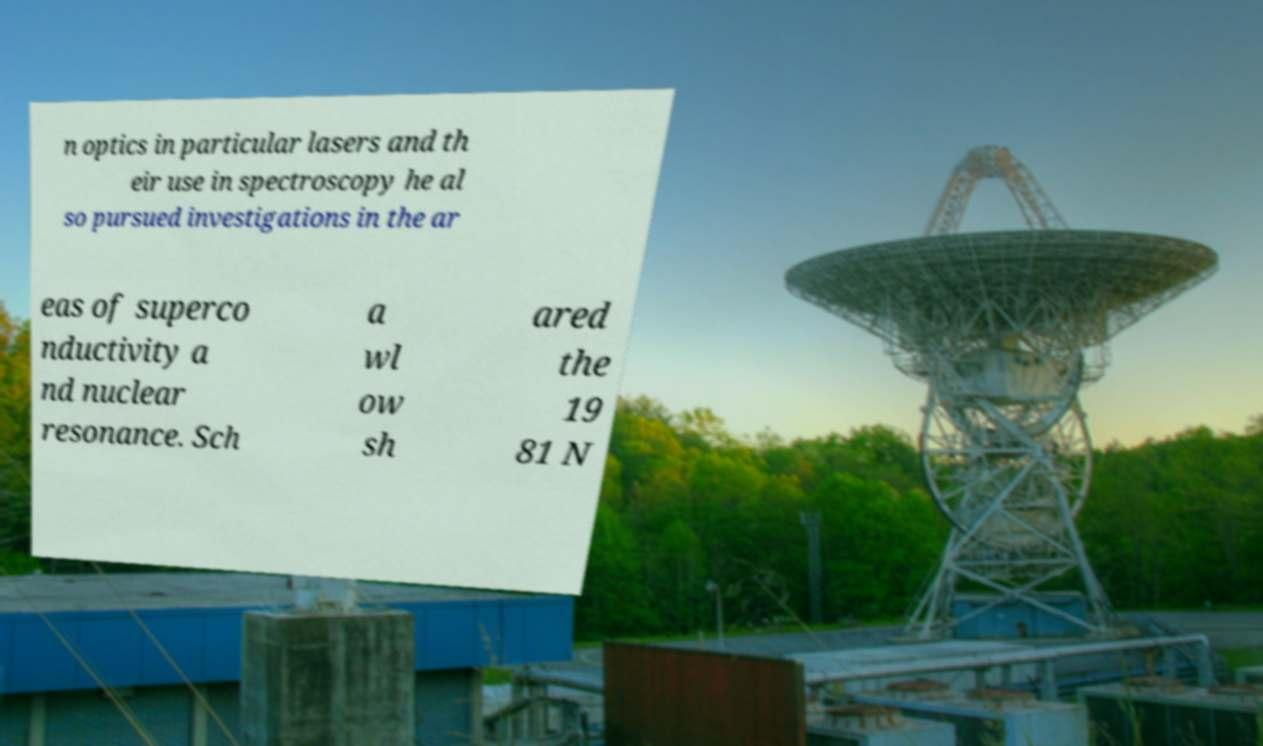There's text embedded in this image that I need extracted. Can you transcribe it verbatim? n optics in particular lasers and th eir use in spectroscopy he al so pursued investigations in the ar eas of superco nductivity a nd nuclear resonance. Sch a wl ow sh ared the 19 81 N 